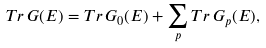Convert formula to latex. <formula><loc_0><loc_0><loc_500><loc_500>T r \, G ( E ) = T r \, G _ { 0 } ( E ) + \sum _ { p } T r \, G _ { p } ( E ) ,</formula> 